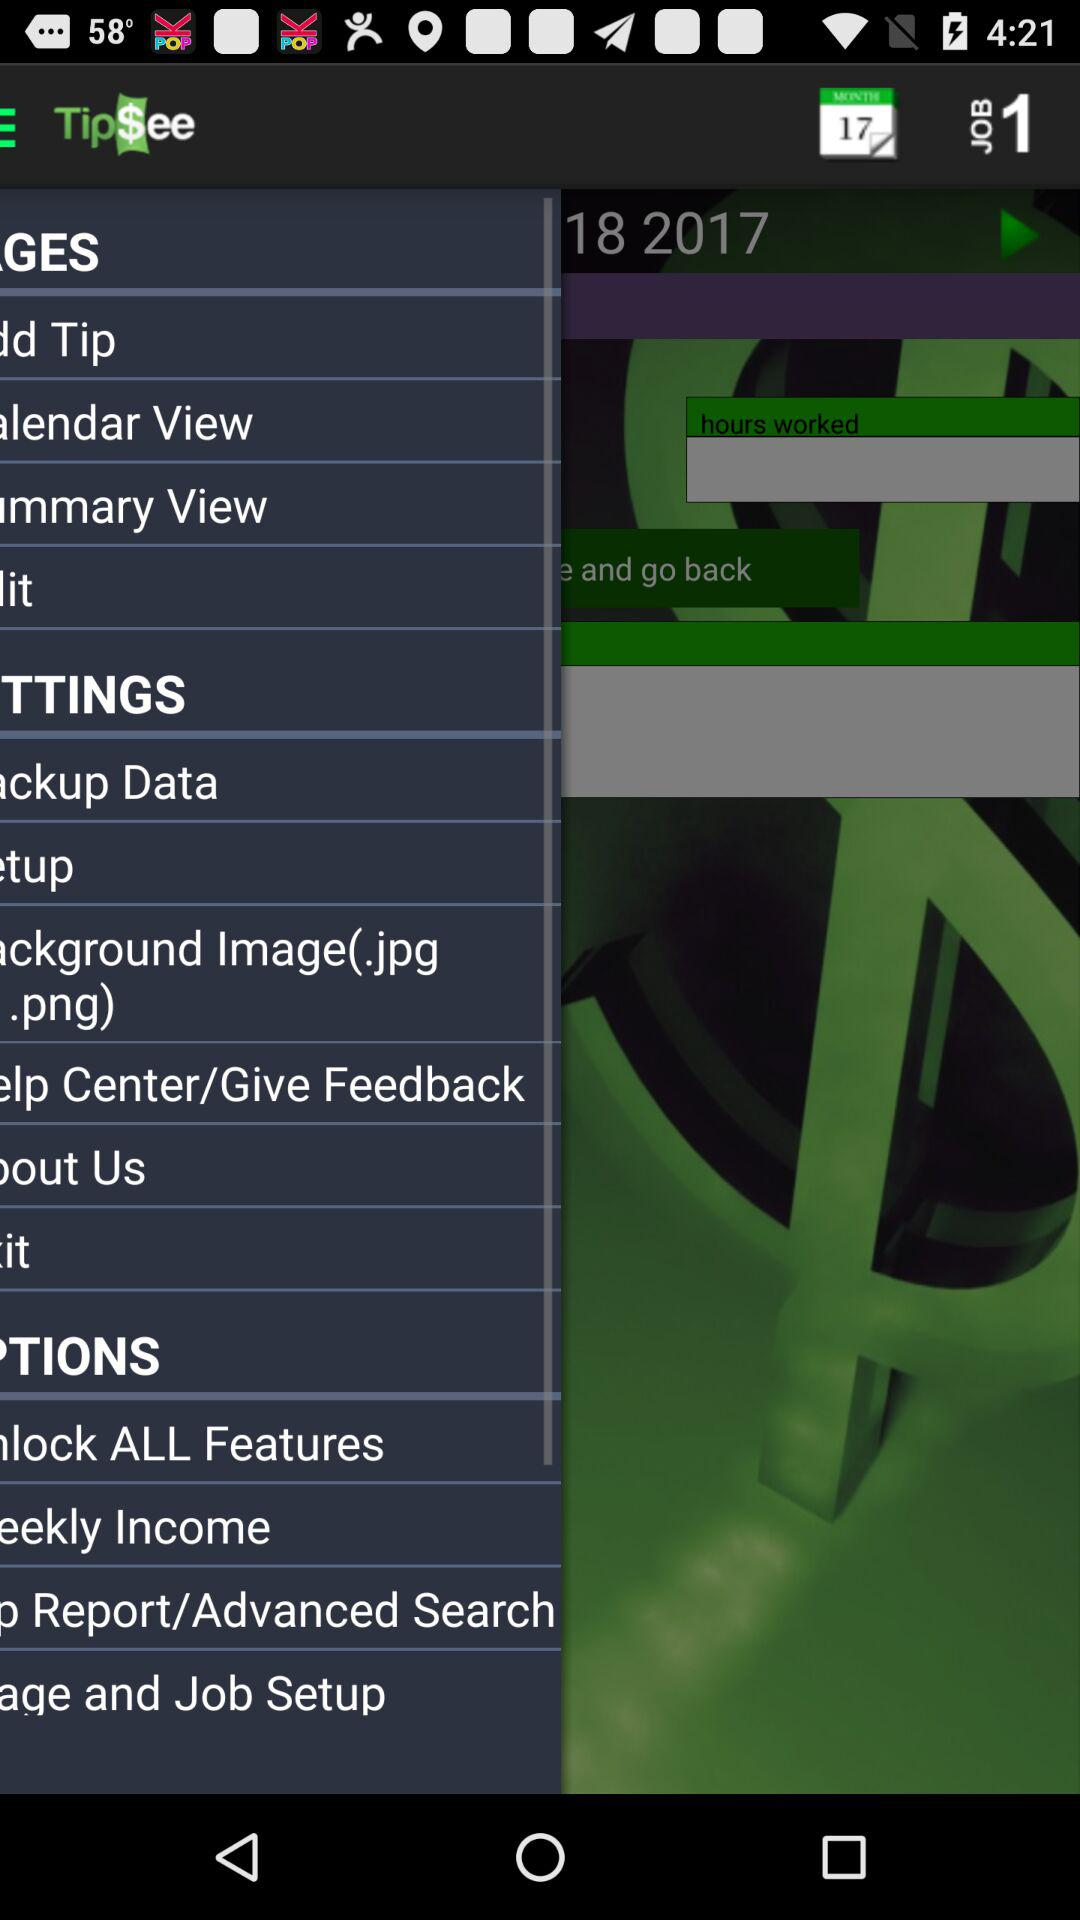What is the highest tip of the day? The highest tip of the day is $0. 